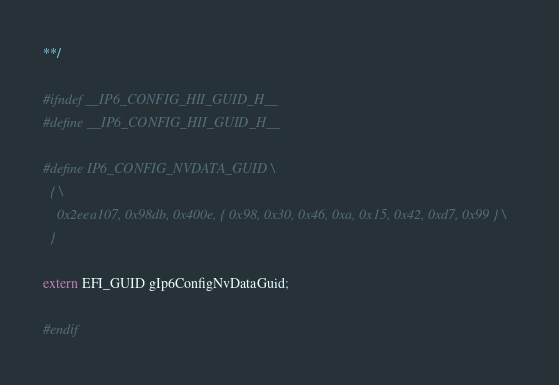<code> <loc_0><loc_0><loc_500><loc_500><_C_>
**/

#ifndef __IP6_CONFIG_HII_GUID_H__
#define __IP6_CONFIG_HII_GUID_H__

#define IP6_CONFIG_NVDATA_GUID \
  { \
    0x2eea107, 0x98db, 0x400e, { 0x98, 0x30, 0x46, 0xa, 0x15, 0x42, 0xd7, 0x99 } \
  }

extern EFI_GUID gIp6ConfigNvDataGuid;

#endif
</code> 